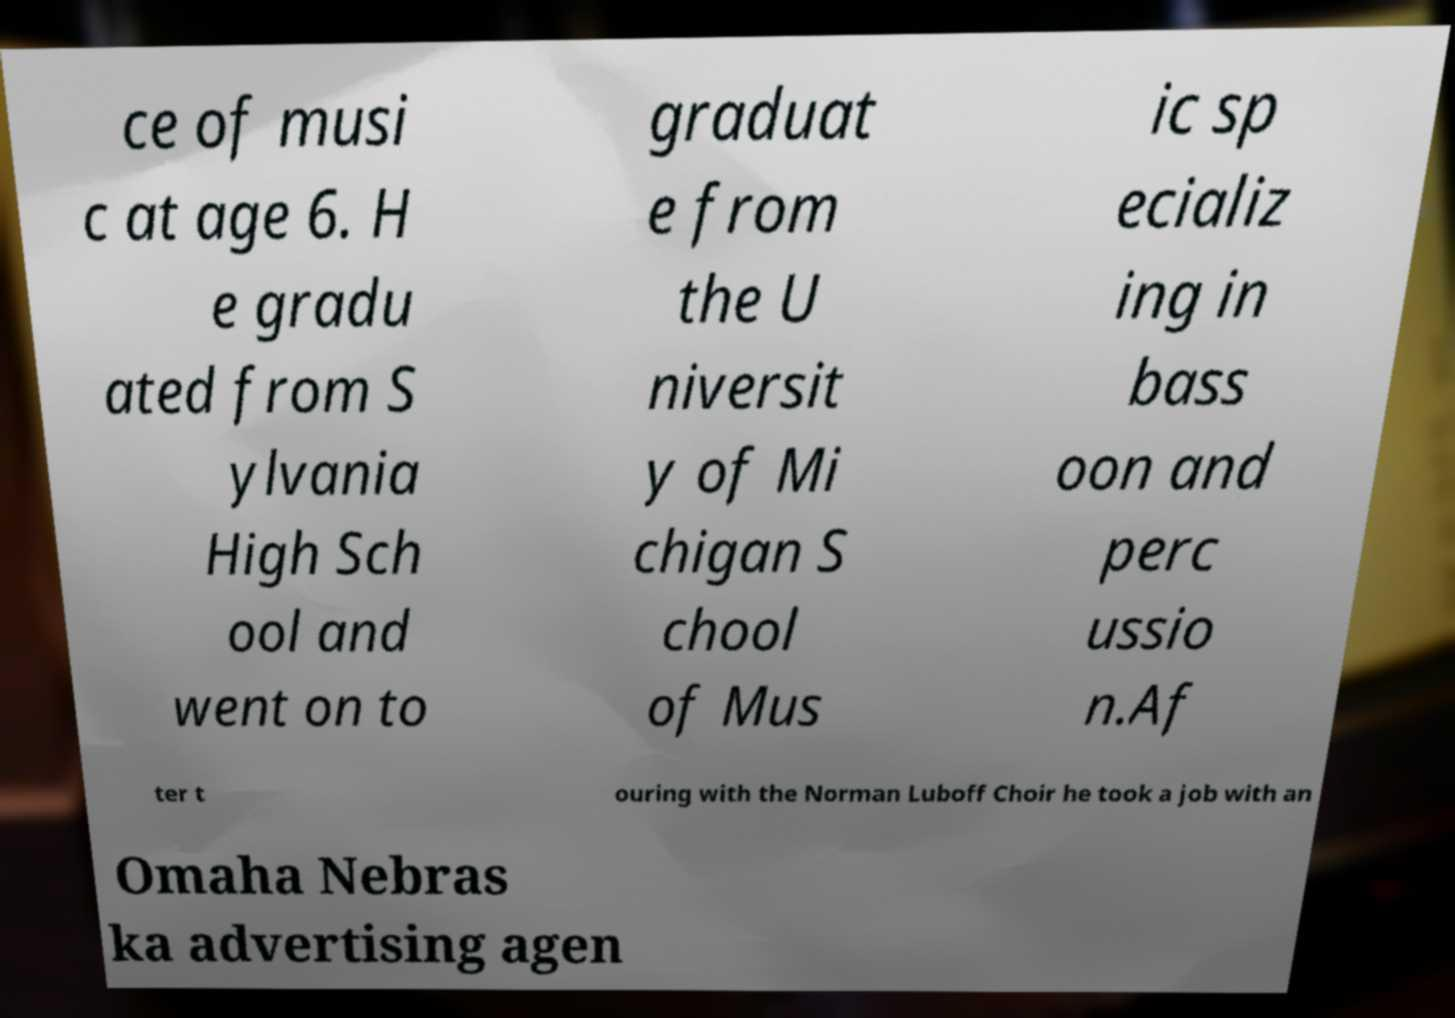Please read and relay the text visible in this image. What does it say? ce of musi c at age 6. H e gradu ated from S ylvania High Sch ool and went on to graduat e from the U niversit y of Mi chigan S chool of Mus ic sp ecializ ing in bass oon and perc ussio n.Af ter t ouring with the Norman Luboff Choir he took a job with an Omaha Nebras ka advertising agen 